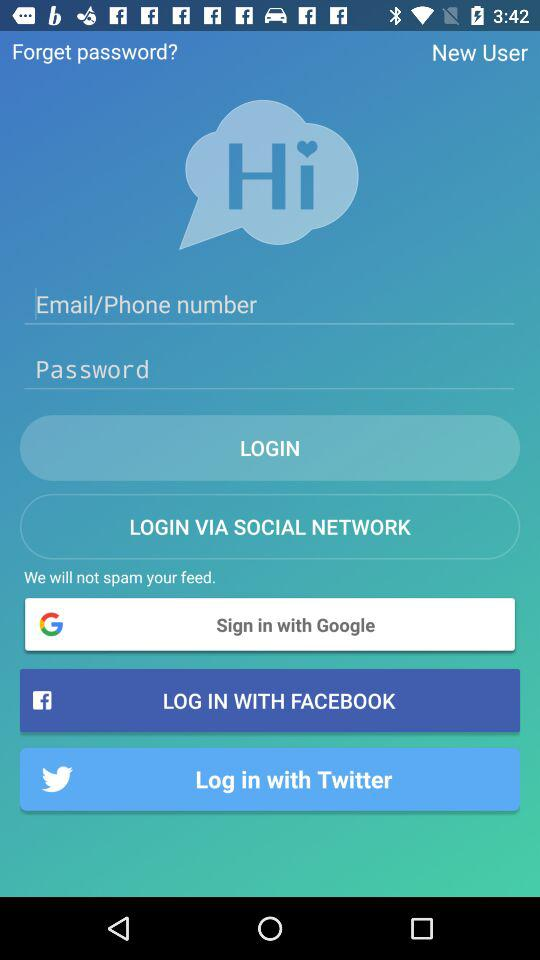How many social media login options are there?
Answer the question using a single word or phrase. 3 